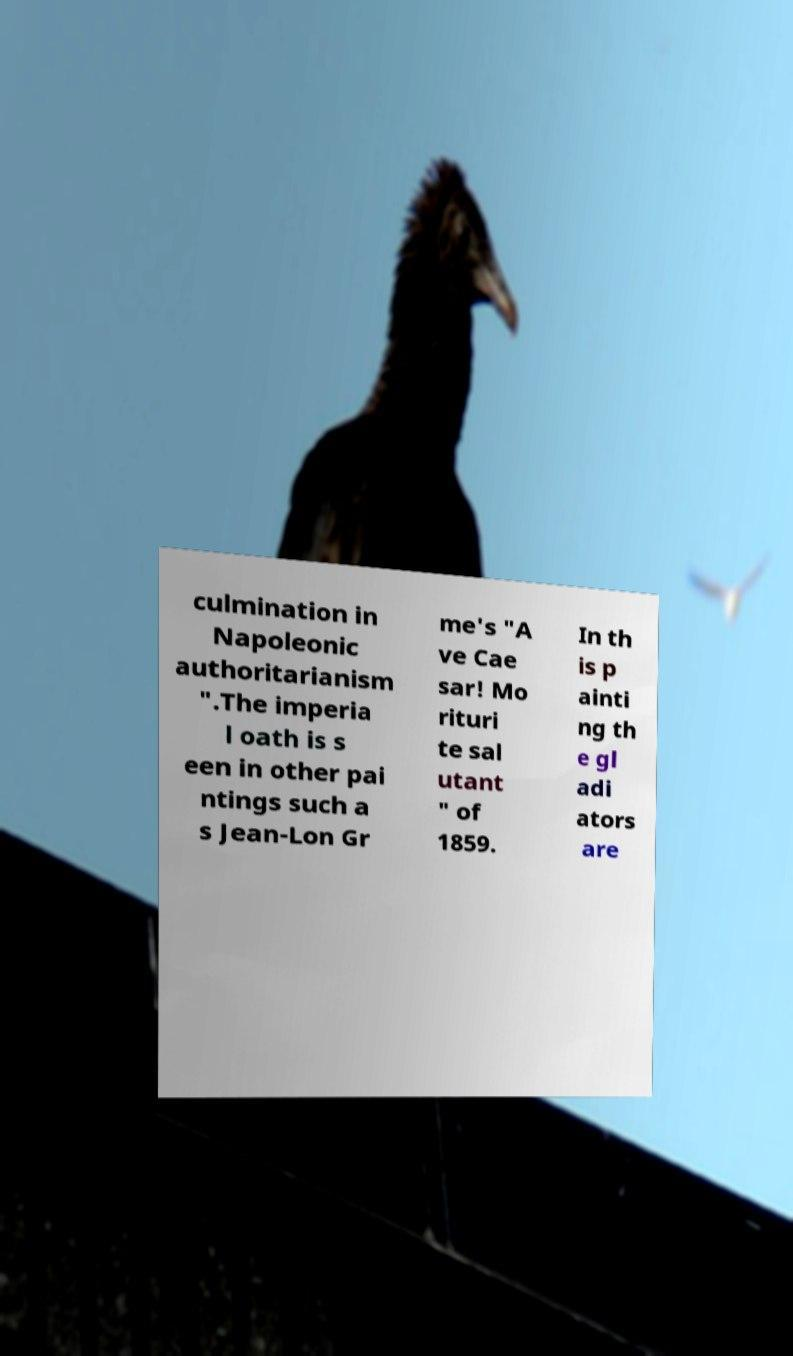Please read and relay the text visible in this image. What does it say? culmination in Napoleonic authoritarianism ".The imperia l oath is s een in other pai ntings such a s Jean-Lon Gr me's "A ve Cae sar! Mo rituri te sal utant " of 1859. In th is p ainti ng th e gl adi ators are 